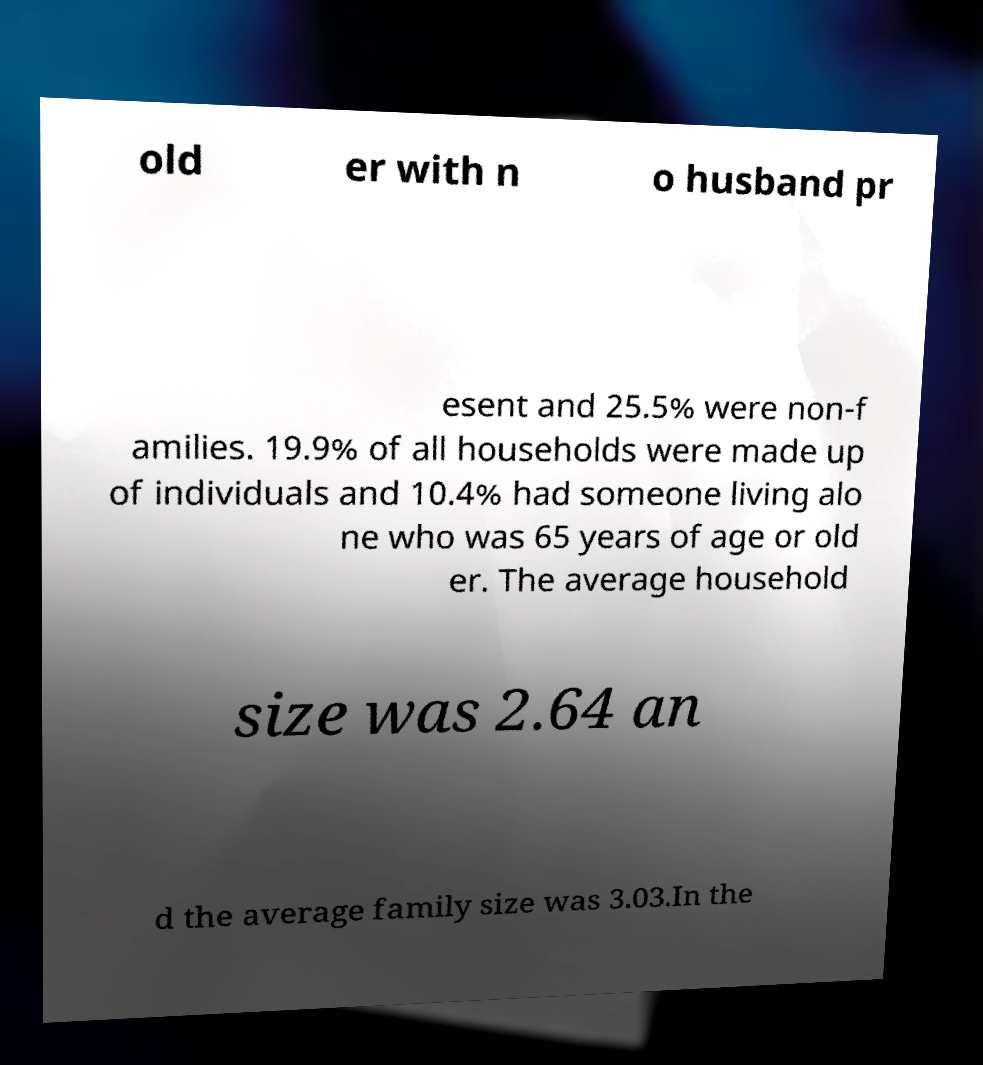Could you assist in decoding the text presented in this image and type it out clearly? old er with n o husband pr esent and 25.5% were non-f amilies. 19.9% of all households were made up of individuals and 10.4% had someone living alo ne who was 65 years of age or old er. The average household size was 2.64 an d the average family size was 3.03.In the 